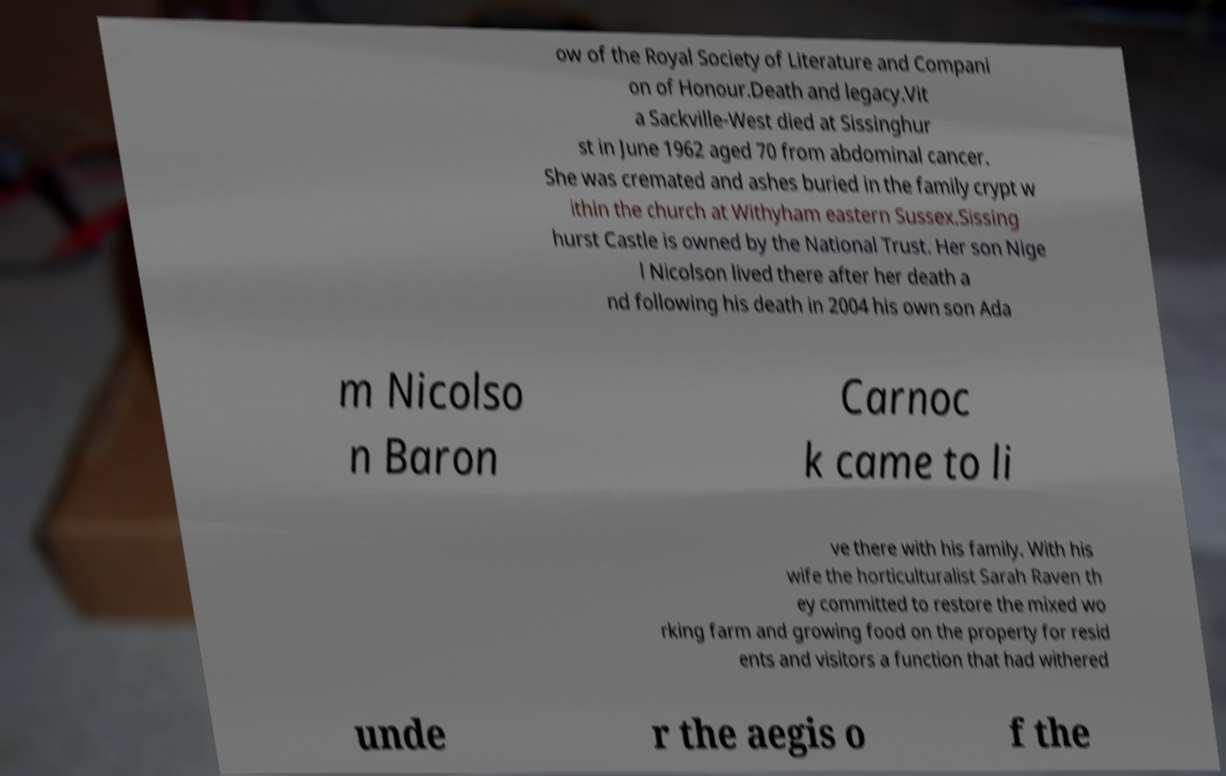For documentation purposes, I need the text within this image transcribed. Could you provide that? ow of the Royal Society of Literature and Compani on of Honour.Death and legacy.Vit a Sackville-West died at Sissinghur st in June 1962 aged 70 from abdominal cancer. She was cremated and ashes buried in the family crypt w ithin the church at Withyham eastern Sussex.Sissing hurst Castle is owned by the National Trust. Her son Nige l Nicolson lived there after her death a nd following his death in 2004 his own son Ada m Nicolso n Baron Carnoc k came to li ve there with his family. With his wife the horticulturalist Sarah Raven th ey committed to restore the mixed wo rking farm and growing food on the property for resid ents and visitors a function that had withered unde r the aegis o f the 